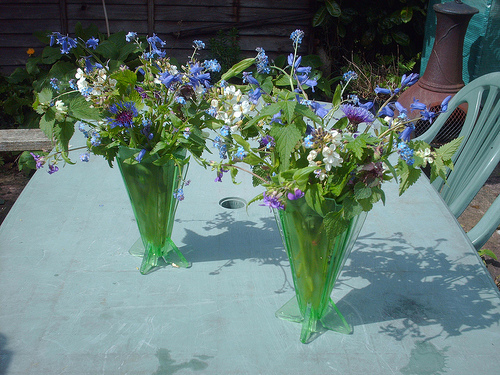Please provide a short description for this region: [0.43, 0.51, 0.5, 0.56]. In the middle of the table lies a circular hole, designed to support a parasol, surrounded by textured marks and shadows on the tabletop. 